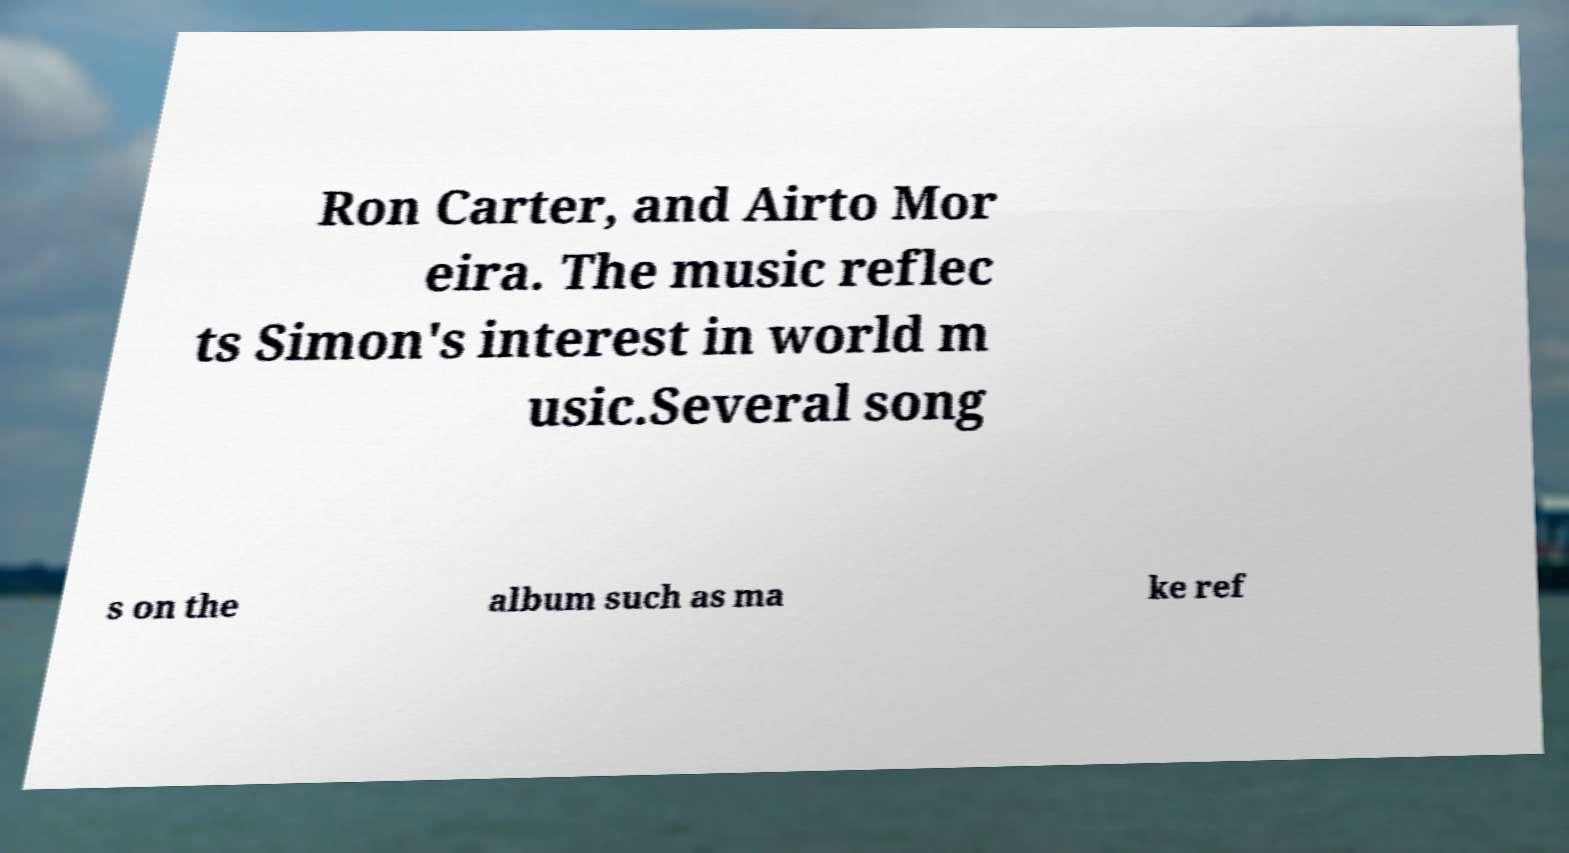Could you extract and type out the text from this image? Ron Carter, and Airto Mor eira. The music reflec ts Simon's interest in world m usic.Several song s on the album such as ma ke ref 